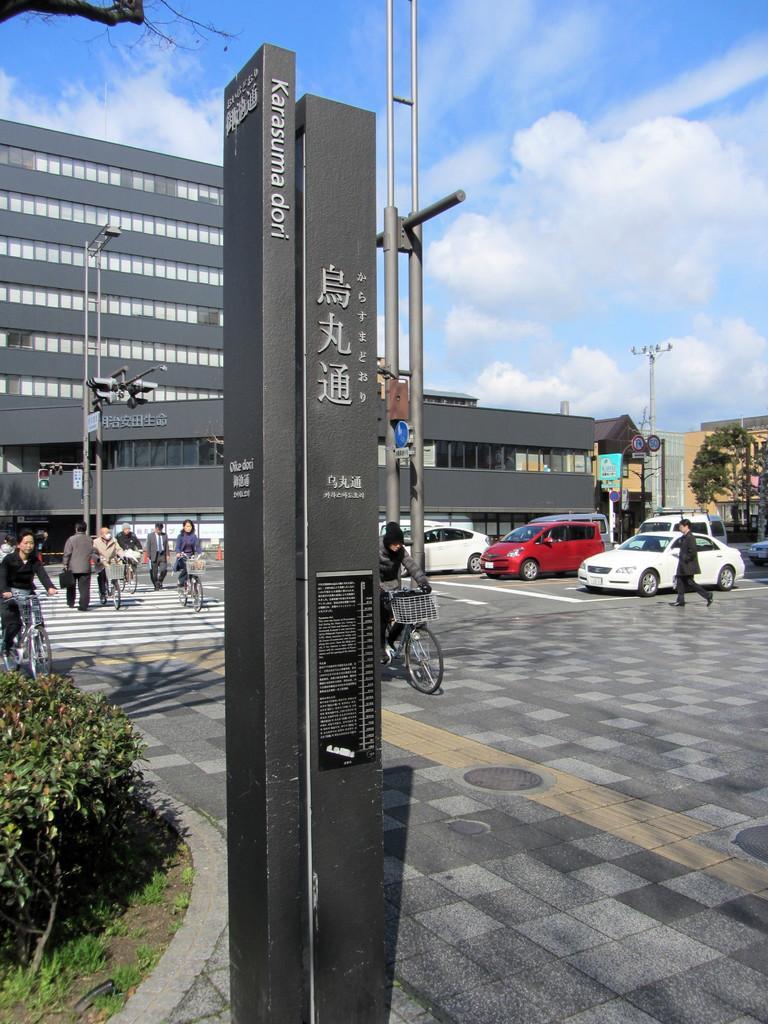Can you describe this image briefly? In this image we can see a few people bicycling and few are walking on the road. Image also consists of buildings, poles and also trees. There are also vehicles passing on the road. At the top there is sky with some clouds. 